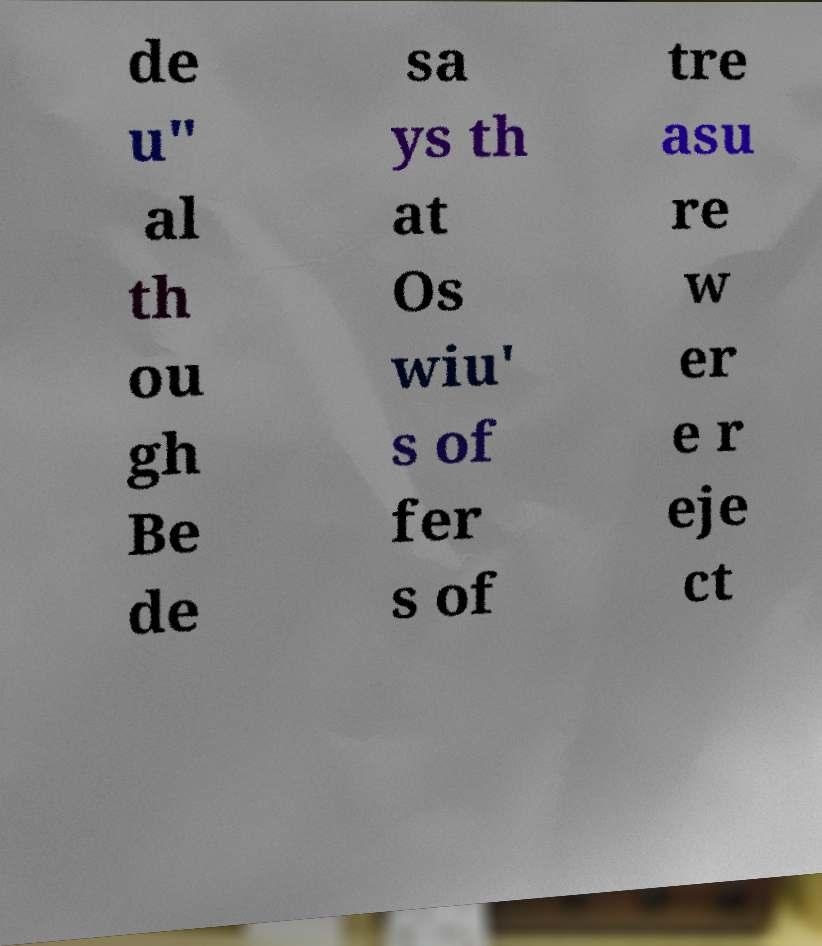Please identify and transcribe the text found in this image. de u" al th ou gh Be de sa ys th at Os wiu' s of fer s of tre asu re w er e r eje ct 